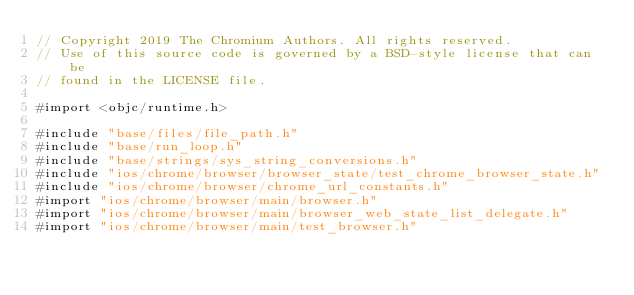<code> <loc_0><loc_0><loc_500><loc_500><_ObjectiveC_>// Copyright 2019 The Chromium Authors. All rights reserved.
// Use of this source code is governed by a BSD-style license that can be
// found in the LICENSE file.

#import <objc/runtime.h>

#include "base/files/file_path.h"
#include "base/run_loop.h"
#include "base/strings/sys_string_conversions.h"
#include "ios/chrome/browser/browser_state/test_chrome_browser_state.h"
#include "ios/chrome/browser/chrome_url_constants.h"
#import "ios/chrome/browser/main/browser.h"
#import "ios/chrome/browser/main/browser_web_state_list_delegate.h"
#import "ios/chrome/browser/main/test_browser.h"</code> 